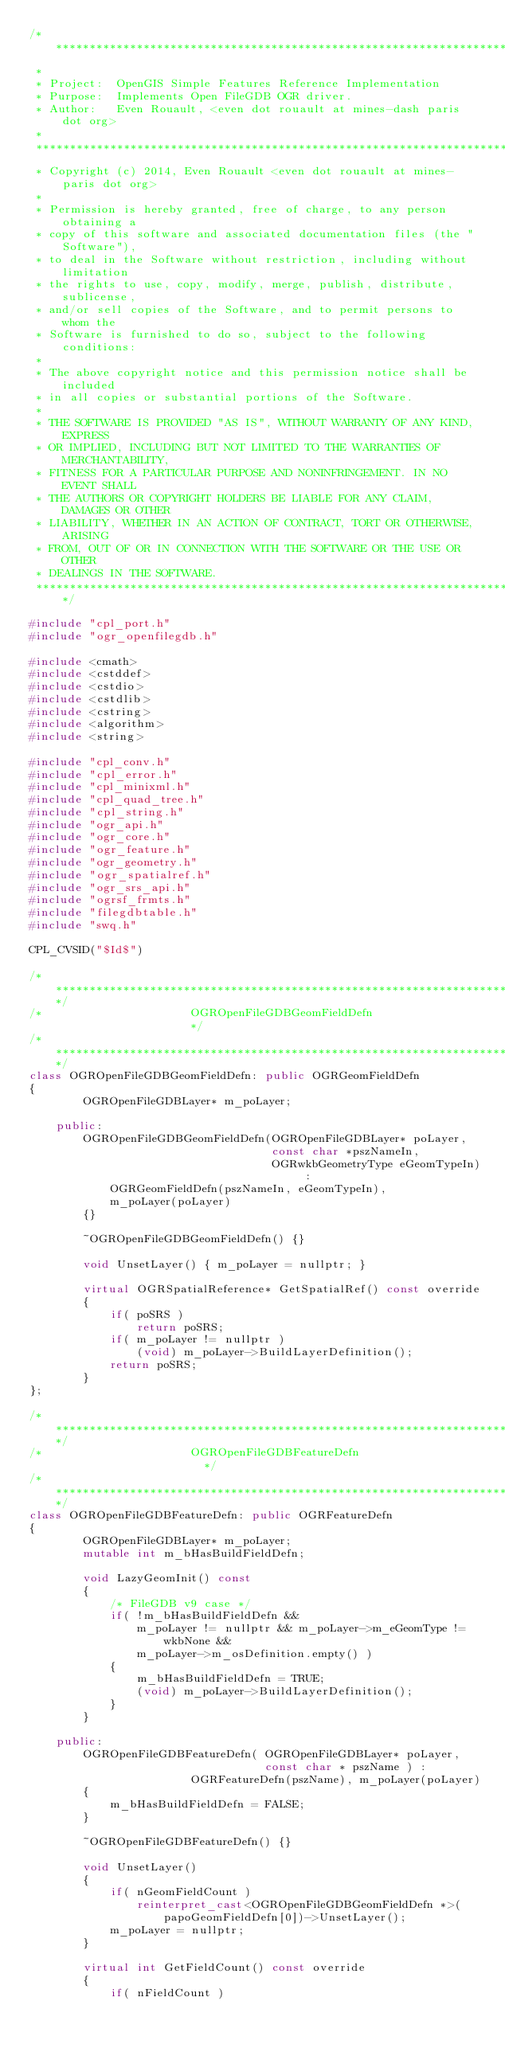<code> <loc_0><loc_0><loc_500><loc_500><_C++_>/******************************************************************************
 *
 * Project:  OpenGIS Simple Features Reference Implementation
 * Purpose:  Implements Open FileGDB OGR driver.
 * Author:   Even Rouault, <even dot rouault at mines-dash paris dot org>
 *
 ******************************************************************************
 * Copyright (c) 2014, Even Rouault <even dot rouault at mines-paris dot org>
 *
 * Permission is hereby granted, free of charge, to any person obtaining a
 * copy of this software and associated documentation files (the "Software"),
 * to deal in the Software without restriction, including without limitation
 * the rights to use, copy, modify, merge, publish, distribute, sublicense,
 * and/or sell copies of the Software, and to permit persons to whom the
 * Software is furnished to do so, subject to the following conditions:
 *
 * The above copyright notice and this permission notice shall be included
 * in all copies or substantial portions of the Software.
 *
 * THE SOFTWARE IS PROVIDED "AS IS", WITHOUT WARRANTY OF ANY KIND, EXPRESS
 * OR IMPLIED, INCLUDING BUT NOT LIMITED TO THE WARRANTIES OF MERCHANTABILITY,
 * FITNESS FOR A PARTICULAR PURPOSE AND NONINFRINGEMENT. IN NO EVENT SHALL
 * THE AUTHORS OR COPYRIGHT HOLDERS BE LIABLE FOR ANY CLAIM, DAMAGES OR OTHER
 * LIABILITY, WHETHER IN AN ACTION OF CONTRACT, TORT OR OTHERWISE, ARISING
 * FROM, OUT OF OR IN CONNECTION WITH THE SOFTWARE OR THE USE OR OTHER
 * DEALINGS IN THE SOFTWARE.
 ****************************************************************************/

#include "cpl_port.h"
#include "ogr_openfilegdb.h"

#include <cmath>
#include <cstddef>
#include <cstdio>
#include <cstdlib>
#include <cstring>
#include <algorithm>
#include <string>

#include "cpl_conv.h"
#include "cpl_error.h"
#include "cpl_minixml.h"
#include "cpl_quad_tree.h"
#include "cpl_string.h"
#include "ogr_api.h"
#include "ogr_core.h"
#include "ogr_feature.h"
#include "ogr_geometry.h"
#include "ogr_spatialref.h"
#include "ogr_srs_api.h"
#include "ogrsf_frmts.h"
#include "filegdbtable.h"
#include "swq.h"

CPL_CVSID("$Id$")

/************************************************************************/
/*                      OGROpenFileGDBGeomFieldDefn                     */
/************************************************************************/
class OGROpenFileGDBGeomFieldDefn: public OGRGeomFieldDefn
{
        OGROpenFileGDBLayer* m_poLayer;

    public:
        OGROpenFileGDBGeomFieldDefn(OGROpenFileGDBLayer* poLayer,
                                    const char *pszNameIn,
                                    OGRwkbGeometryType eGeomTypeIn) :
            OGRGeomFieldDefn(pszNameIn, eGeomTypeIn),
            m_poLayer(poLayer)
        {}

        ~OGROpenFileGDBGeomFieldDefn() {}

        void UnsetLayer() { m_poLayer = nullptr; }

        virtual OGRSpatialReference* GetSpatialRef() const override
        {
            if( poSRS )
                return poSRS;
            if( m_poLayer != nullptr )
                (void) m_poLayer->BuildLayerDefinition();
            return poSRS;
        }
};

/************************************************************************/
/*                      OGROpenFileGDBFeatureDefn                       */
/************************************************************************/
class OGROpenFileGDBFeatureDefn: public OGRFeatureDefn
{
        OGROpenFileGDBLayer* m_poLayer;
        mutable int m_bHasBuildFieldDefn;

        void LazyGeomInit() const
        {
            /* FileGDB v9 case */
            if( !m_bHasBuildFieldDefn &&
                m_poLayer != nullptr && m_poLayer->m_eGeomType != wkbNone &&
                m_poLayer->m_osDefinition.empty() )
            {
                m_bHasBuildFieldDefn = TRUE;
                (void) m_poLayer->BuildLayerDefinition();
            }
        }

    public:
        OGROpenFileGDBFeatureDefn( OGROpenFileGDBLayer* poLayer,
                                   const char * pszName ) :
                        OGRFeatureDefn(pszName), m_poLayer(poLayer)
        {
            m_bHasBuildFieldDefn = FALSE;
        }

        ~OGROpenFileGDBFeatureDefn() {}

        void UnsetLayer()
        {
            if( nGeomFieldCount )
                reinterpret_cast<OGROpenFileGDBGeomFieldDefn *>(
                    papoGeomFieldDefn[0])->UnsetLayer();
            m_poLayer = nullptr;
        }

        virtual int GetFieldCount() const override
        {
            if( nFieldCount )</code> 